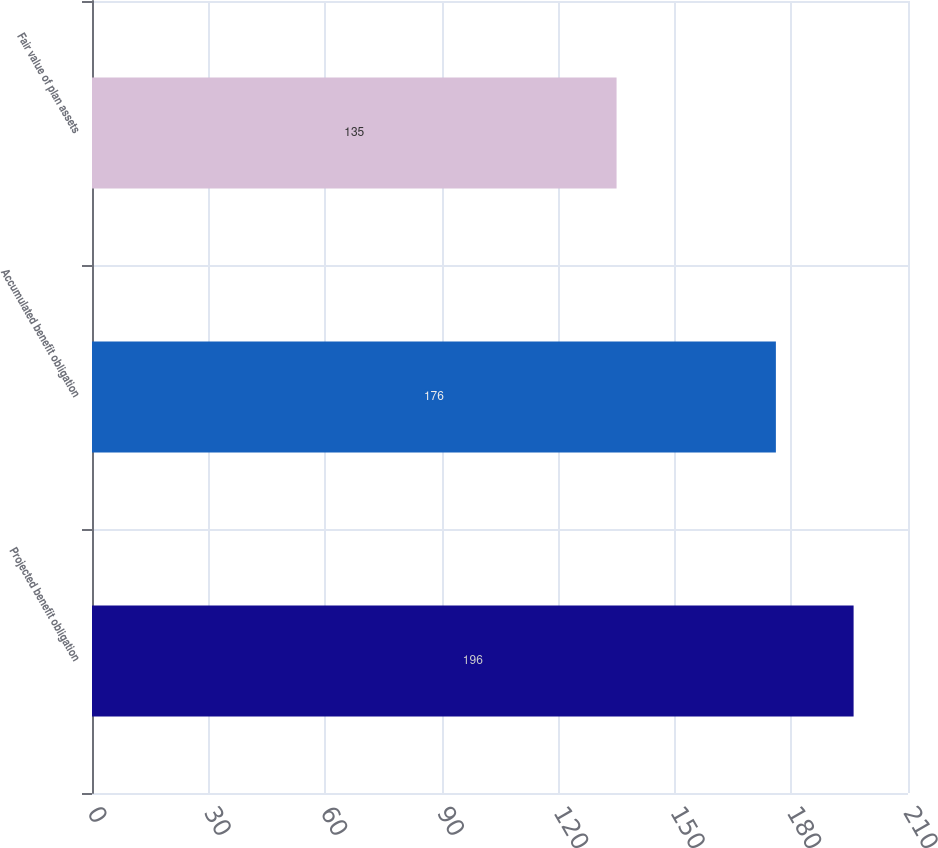Convert chart. <chart><loc_0><loc_0><loc_500><loc_500><bar_chart><fcel>Projected benefit obligation<fcel>Accumulated benefit obligation<fcel>Fair value of plan assets<nl><fcel>196<fcel>176<fcel>135<nl></chart> 